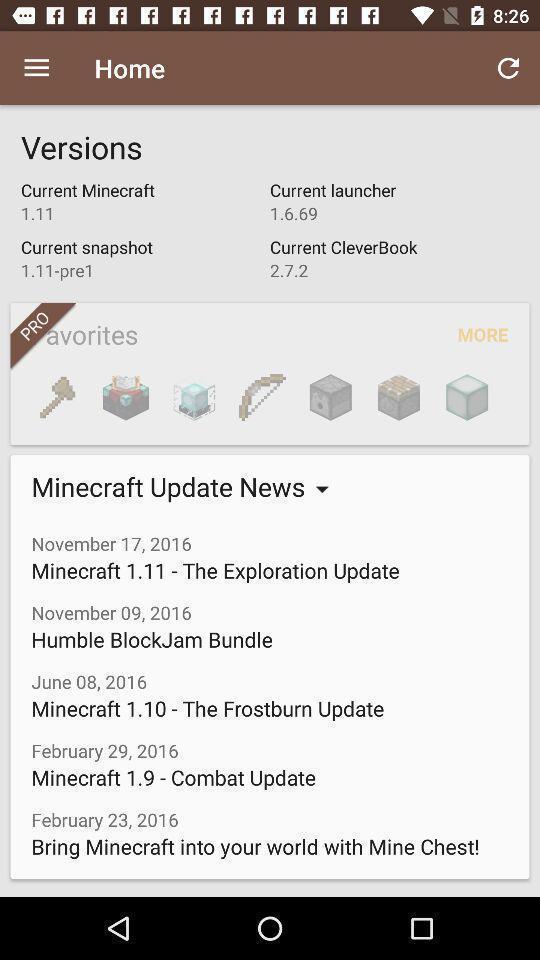Provide a description of this screenshot. Version page showing in application. 